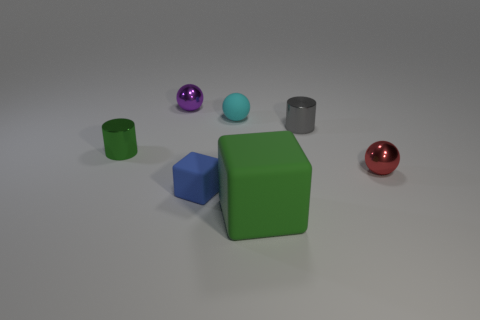Add 2 tiny shiny things. How many objects exist? 9 Subtract all cubes. How many objects are left? 5 Subtract all gray matte cubes. Subtract all tiny blue rubber blocks. How many objects are left? 6 Add 1 metal cylinders. How many metal cylinders are left? 3 Add 1 small green matte balls. How many small green matte balls exist? 1 Subtract 0 red blocks. How many objects are left? 7 